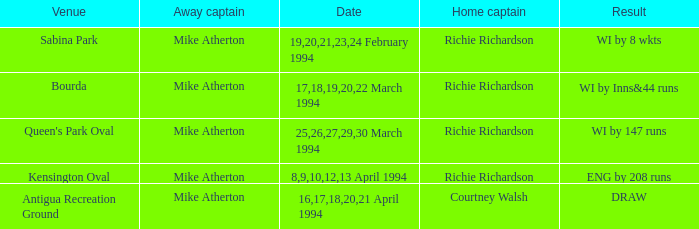Which Home captain has Date of 25,26,27,29,30 march 1994? Richie Richardson. 